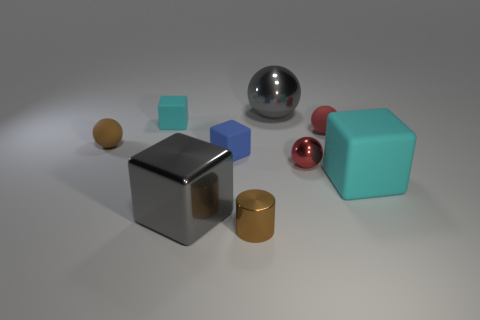Subtract all red balls. How many were subtracted if there are1red balls left? 1 Add 1 small brown rubber things. How many objects exist? 10 Subtract all balls. How many objects are left? 5 Subtract all tiny objects. Subtract all tiny metallic cylinders. How many objects are left? 2 Add 9 big matte things. How many big matte things are left? 10 Add 9 large green shiny cubes. How many large green shiny cubes exist? 9 Subtract 1 blue blocks. How many objects are left? 8 